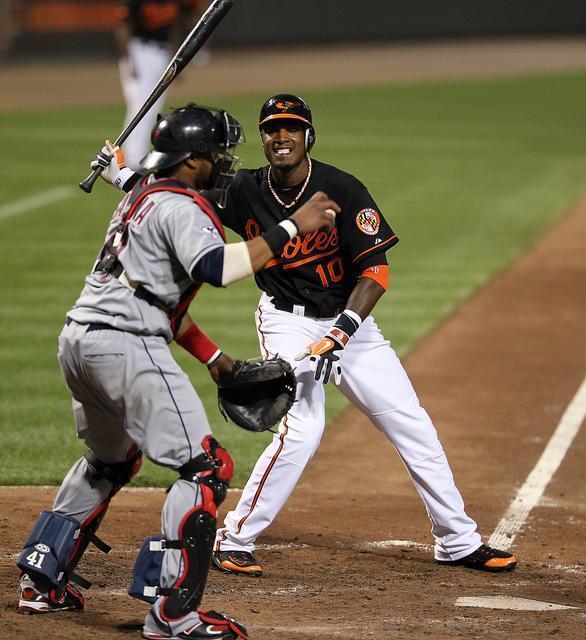How many baseball bats can you see?
Give a very brief answer. 1. How many people are in the photo?
Give a very brief answer. 2. 